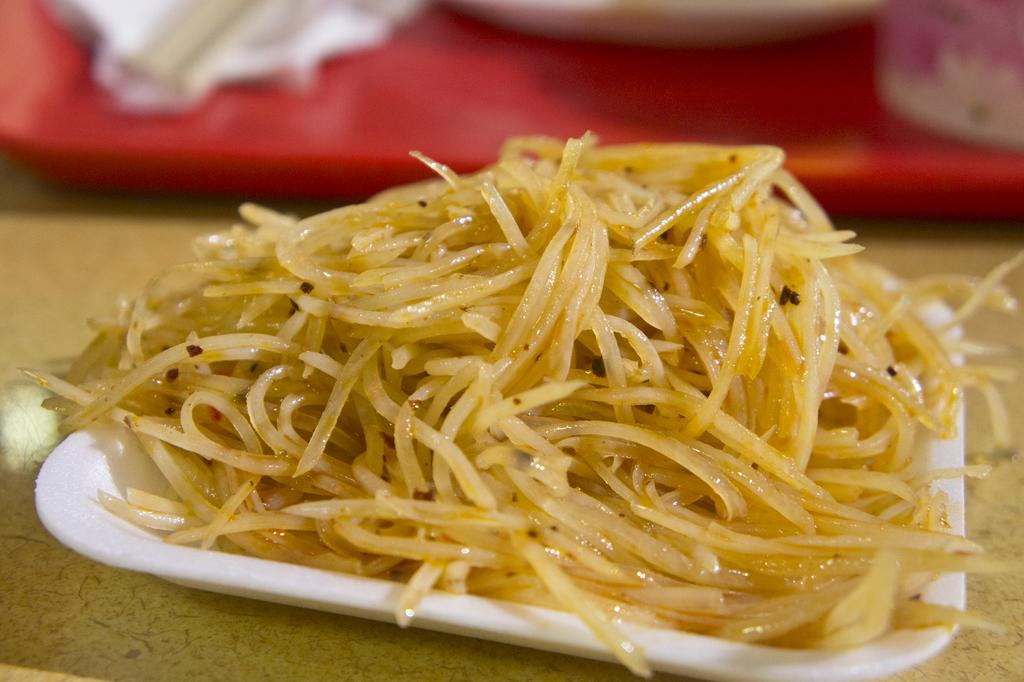What is in the plate that is visible in the image? There are noodles in a plate in the image. Where is the plate with noodles located? The plate with noodles is placed on a table in the image. What type of garden can be seen growing in the plate with noodles? There is no garden present in the plate with noodles; it contains noodles. 